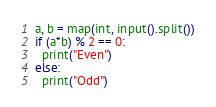<code> <loc_0><loc_0><loc_500><loc_500><_Python_>a, b = map(int, input().split())
if (a*b) % 2 == 0:
  print("Even")
else:
  print("Odd")</code> 